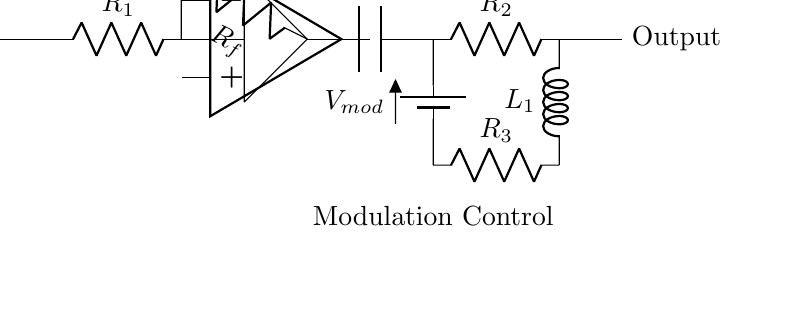What is the input component in this circuit? The input component is indicated as 'Input' and connects directly to a resistor, showing it starts the signal path.
Answer: Input What type of amplifier is used in the circuit? The circuit includes an operational amplifier, usually represented by the op amp symbol, which is critical for signal processing.
Answer: Operational amplifier What is the function of the capacitor in this circuit? The capacitor, labeled 'C1', typically serves to couple or filter signals, affecting the frequency response of the modulation circuit.
Answer: Coupling/Filtering What does 'Rf' represent in the circuit? 'Rf' is the feedback resistor connected from the output of the operational amplifier back to its inverting input, influencing gain and stability.
Answer: Feedback resistor How many resistors are present in this circuit? There are three resistors labeled 'R1', 'R2', and 'R3', which can affect the overall resistance and circuit behavior.
Answer: Three What is the role of the inductor in the modulation circuit? The inductor, labeled 'L1', typically reacts to changes in current and can help shape the frequency response by allowing certain frequencies to pass while blocking others.
Answer: Frequency shaping What is the power source used for the modulation control? The battery, labeled 'Vmod', is used as a power source specifically for the modulation control section of the circuit.
Answer: Battery 